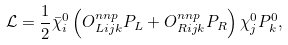Convert formula to latex. <formula><loc_0><loc_0><loc_500><loc_500>\mathcal { L } = \frac { 1 } { 2 } \bar { \chi } _ { i } ^ { 0 } \left ( O _ { L i j k } ^ { n n p } P _ { L } + O _ { R i j k } ^ { n n p } P _ { R } \right ) \chi _ { j } ^ { 0 } P _ { k } ^ { 0 } ,</formula> 